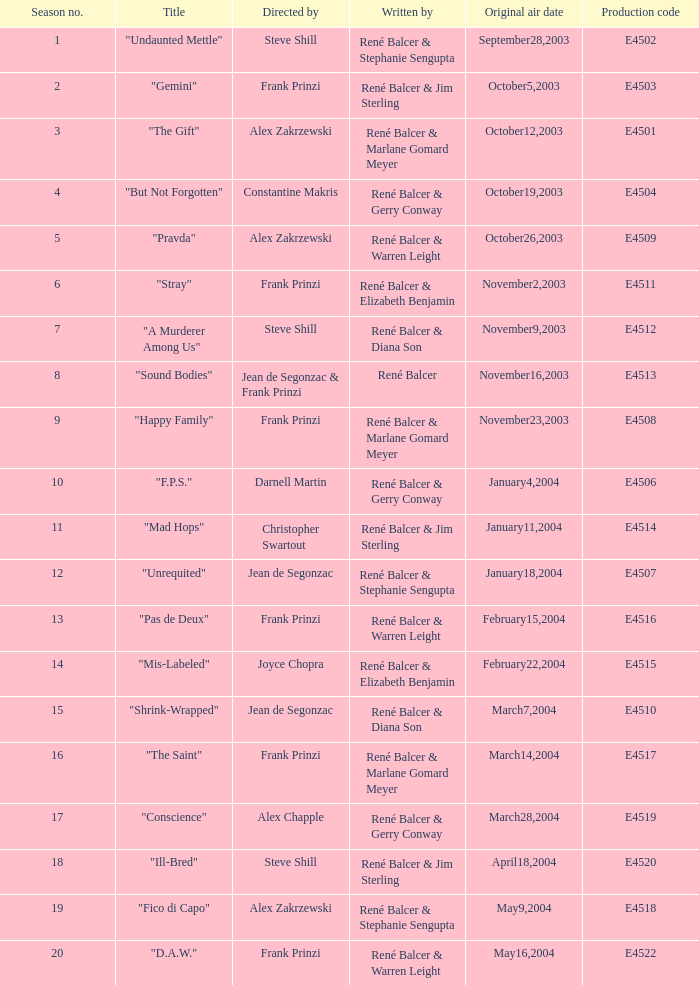Who wrote the episode with e4515 as the production code? René Balcer & Elizabeth Benjamin. 